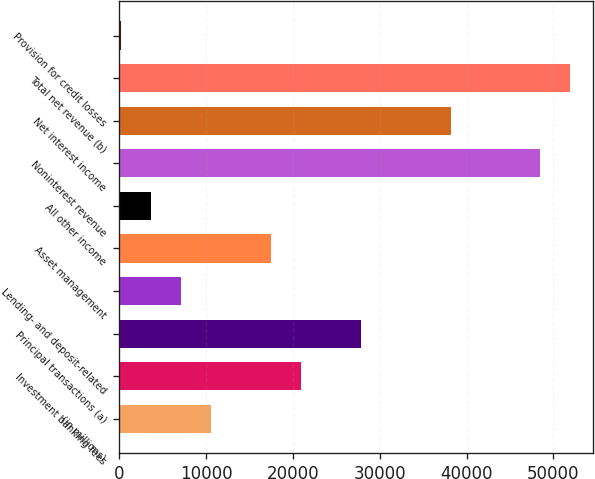Convert chart. <chart><loc_0><loc_0><loc_500><loc_500><bar_chart><fcel>(in millions)<fcel>Investment banking fees<fcel>Principal transactions (a)<fcel>Lending- and deposit-related<fcel>Asset management<fcel>All other income<fcel>Noninterest revenue<fcel>Net interest income<fcel>Total net revenue (b)<fcel>Provision for credit losses<nl><fcel>10576<fcel>20920<fcel>27816<fcel>7128<fcel>17472<fcel>3680<fcel>48504<fcel>38160<fcel>51952<fcel>232<nl></chart> 